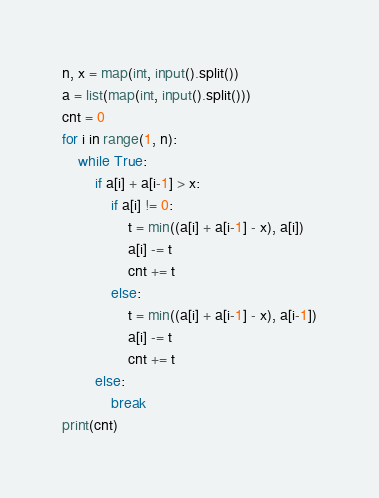Convert code to text. <code><loc_0><loc_0><loc_500><loc_500><_Python_>n, x = map(int, input().split())
a = list(map(int, input().split()))
cnt = 0
for i in range(1, n):
    while True:
        if a[i] + a[i-1] > x:
            if a[i] != 0:
                t = min((a[i] + a[i-1] - x), a[i])
                a[i] -= t
                cnt += t
            else:
                t = min((a[i] + a[i-1] - x), a[i-1])
                a[i] -= t
                cnt += t
        else:
            break
print(cnt)
</code> 